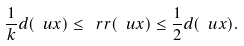<formula> <loc_0><loc_0><loc_500><loc_500>\frac { 1 } { k } d ( \ u x ) \leq \ r r ( \ u x ) \leq \frac { 1 } { 2 } d ( \ u x ) .</formula> 